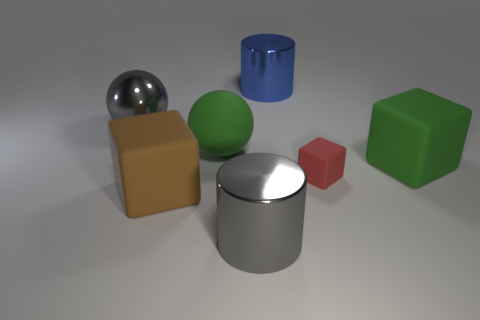Is there any other thing that has the same material as the green sphere?
Offer a very short reply. Yes. What size is the rubber cube left of the large rubber sphere?
Your response must be concise. Large. What is the red block made of?
Offer a very short reply. Rubber. There is a tiny object on the right side of the large ball right of the gray ball; what is its shape?
Provide a succinct answer. Cube. How many other things are the same shape as the big brown matte thing?
Give a very brief answer. 2. Are there any big brown things behind the brown block?
Keep it short and to the point. No. The metal sphere is what color?
Provide a succinct answer. Gray. There is a rubber sphere; is its color the same as the large rubber object that is in front of the tiny red block?
Ensure brevity in your answer.  No. Is there a green matte cube that has the same size as the brown cube?
Offer a terse response. Yes. There is a object that is the same color as the large rubber ball; what is its size?
Provide a succinct answer. Large. 